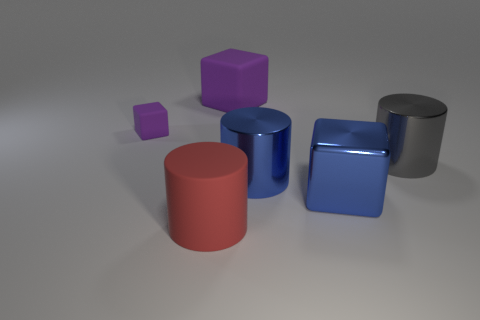There is a big cylinder left of the metallic cylinder left of the gray cylinder; what color is it?
Your answer should be very brief. Red. How many big purple things are there?
Make the answer very short. 1. Does the large matte cylinder have the same color as the small block?
Your answer should be very brief. No. Is the number of shiny cubes behind the big gray shiny cylinder less than the number of big blue blocks that are behind the small matte thing?
Offer a very short reply. No. The tiny matte object has what color?
Offer a very short reply. Purple. How many small blocks have the same color as the big rubber cube?
Offer a very short reply. 1. There is a metallic cube; are there any large red rubber cylinders on the right side of it?
Your answer should be compact. No. Is the number of big gray metal cylinders that are in front of the blue metallic cube the same as the number of big blue metal cubes that are behind the large matte cylinder?
Keep it short and to the point. No. There is a gray metallic cylinder to the right of the blue cylinder; does it have the same size as the purple cube that is on the right side of the red rubber cylinder?
Keep it short and to the point. Yes. There is a large rubber thing in front of the big matte thing that is behind the metallic cylinder that is in front of the gray thing; what is its shape?
Give a very brief answer. Cylinder. 